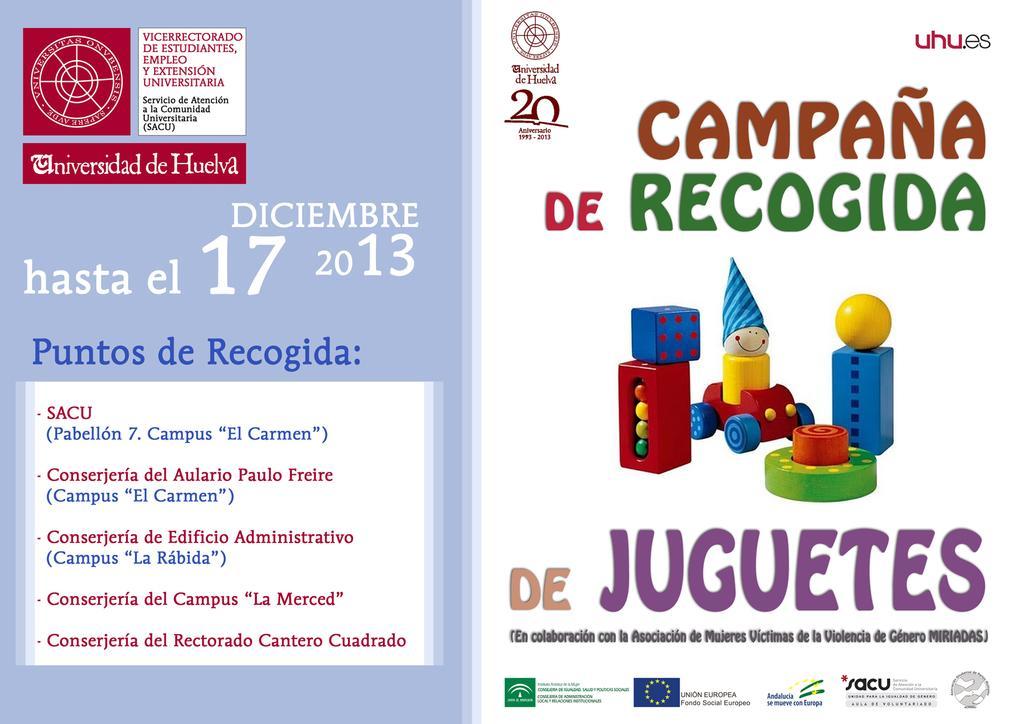Can you describe this image briefly? There is a graphic image with spanish text all over it and some toy pictures in the middle. 